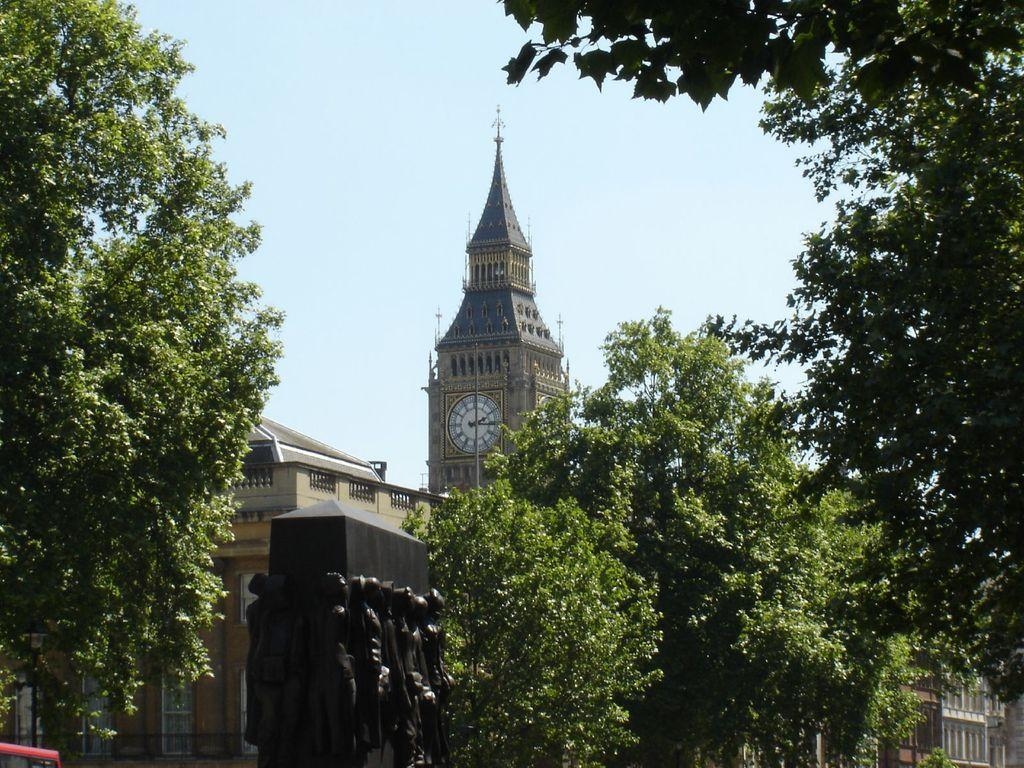What is the main structure in the center of the image? There is a clock tower in the center of the image. What other structures can be seen in the image? There are buildings visible in the image. What is located at the bottom of the image? There is a sculpture at the bottom of the image. What type of vegetation is present in the image? Trees are present in the image. What can be seen in the background of the image? The sky is visible in the background of the image. What type of snake can be seen slithering through the clock tower in the image? There is no snake present in the image; the focus is on the clock tower, buildings, sculpture, trees, and sky. 